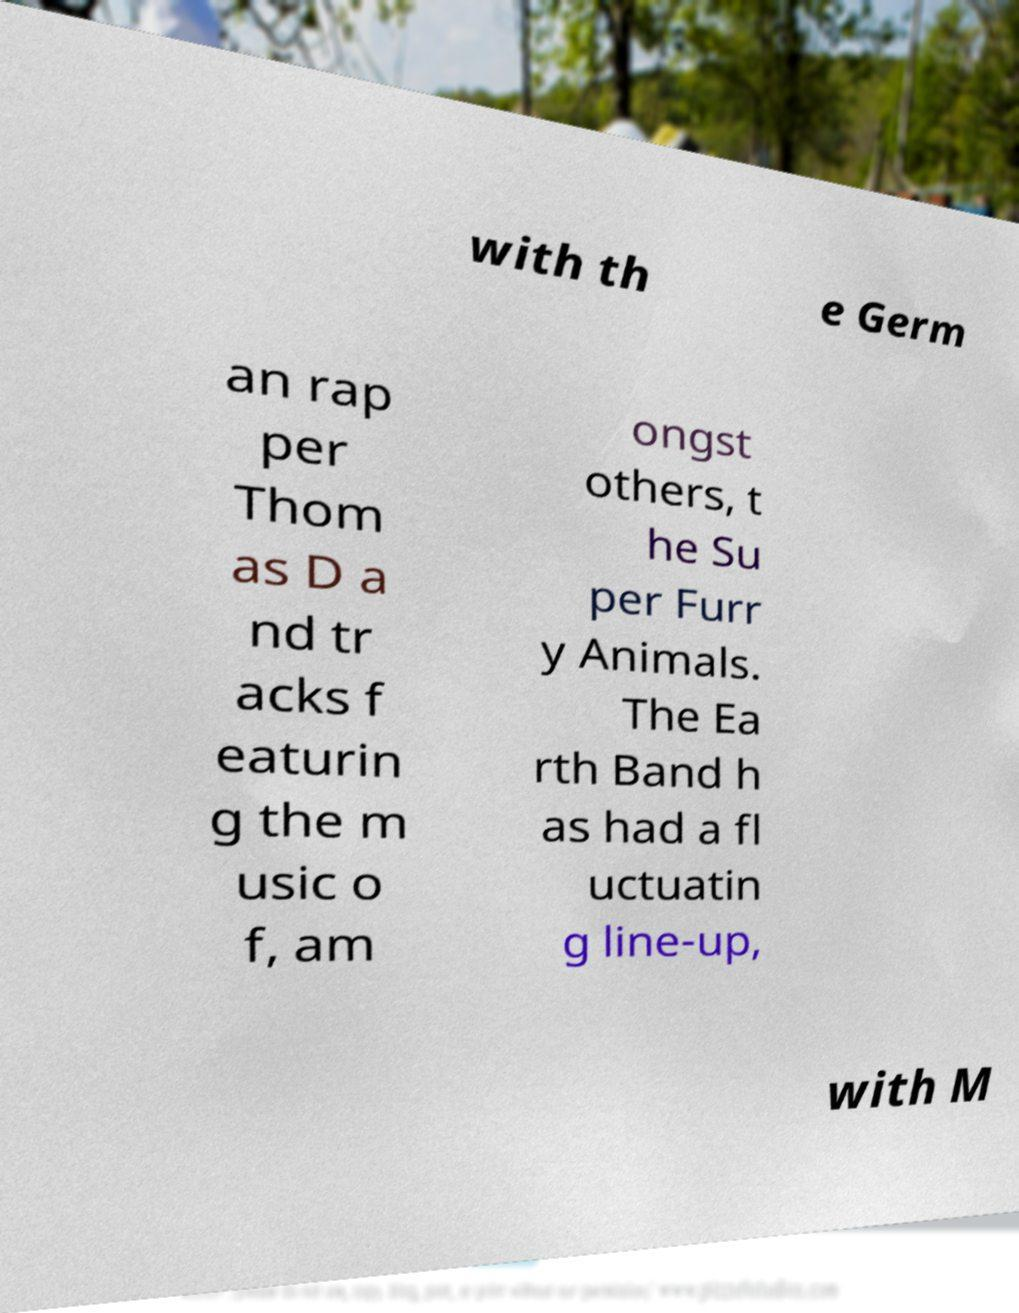Please identify and transcribe the text found in this image. with th e Germ an rap per Thom as D a nd tr acks f eaturin g the m usic o f, am ongst others, t he Su per Furr y Animals. The Ea rth Band h as had a fl uctuatin g line-up, with M 